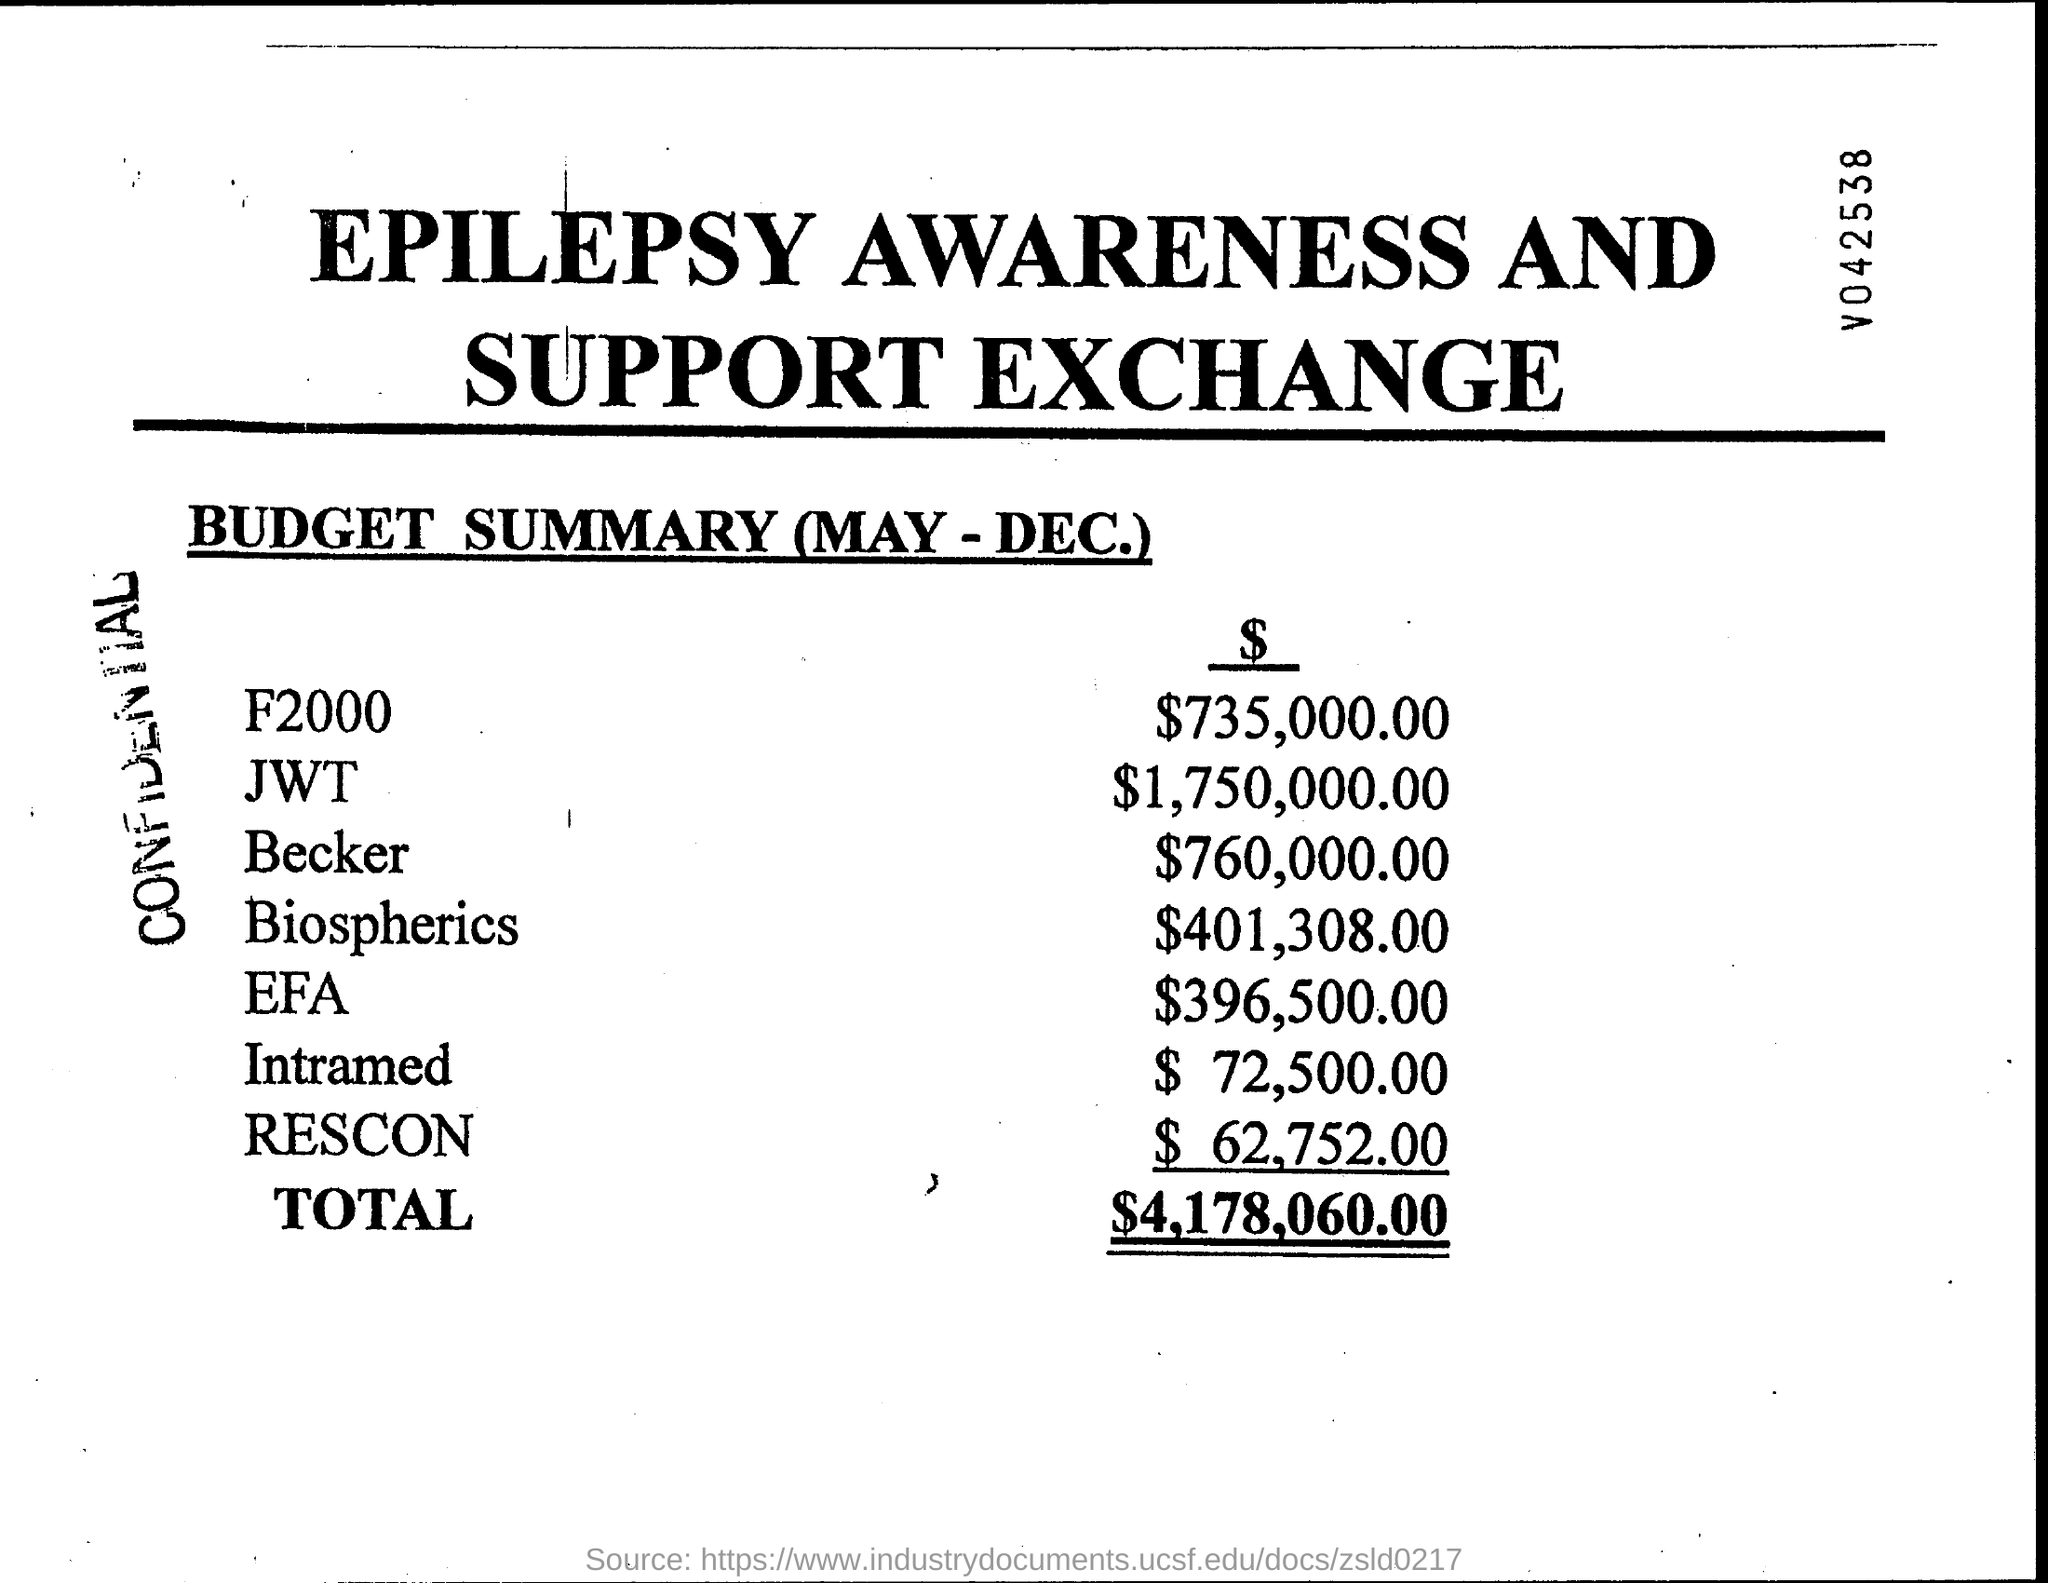List a handful of essential elements in this visual. The total budget is $4,178,060.00. 